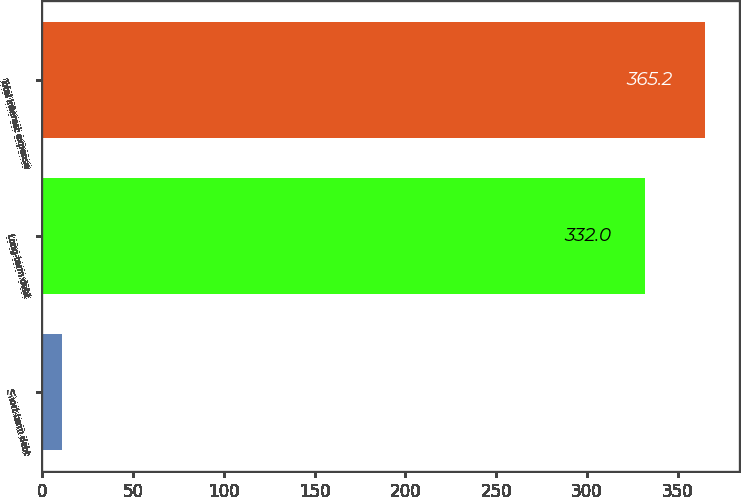Convert chart. <chart><loc_0><loc_0><loc_500><loc_500><bar_chart><fcel>Short-term debt<fcel>Long-term debt<fcel>Total interest expense<nl><fcel>11<fcel>332<fcel>365.2<nl></chart> 